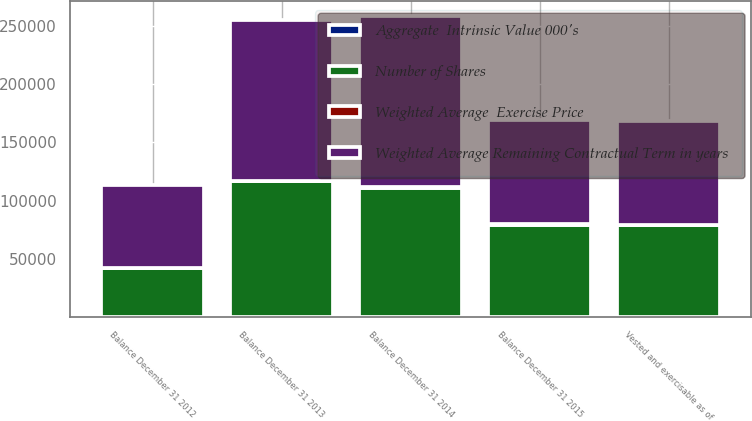Convert chart. <chart><loc_0><loc_0><loc_500><loc_500><stacked_bar_chart><ecel><fcel>Balance December 31 2012<fcel>Balance December 31 2013<fcel>Balance December 31 2014<fcel>Balance December 31 2015<fcel>Vested and exercisable as of<nl><fcel>Weighted Average Remaining Contractual Term in years<fcel>71001<fcel>137708<fcel>146385<fcel>89104<fcel>88687<nl><fcel>Weighted Average  Exercise Price<fcel>19.73<fcel>315.36<fcel>380.05<fcel>383.03<fcel>383.06<nl><fcel>Number of Shares<fcel>42647<fcel>116686<fcel>111277<fcel>79474<fcel>79099<nl><fcel>Aggregate  Intrinsic Value 000's<fcel>1.3<fcel>6.6<fcel>6.5<fcel>5.4<fcel>5.4<nl></chart> 